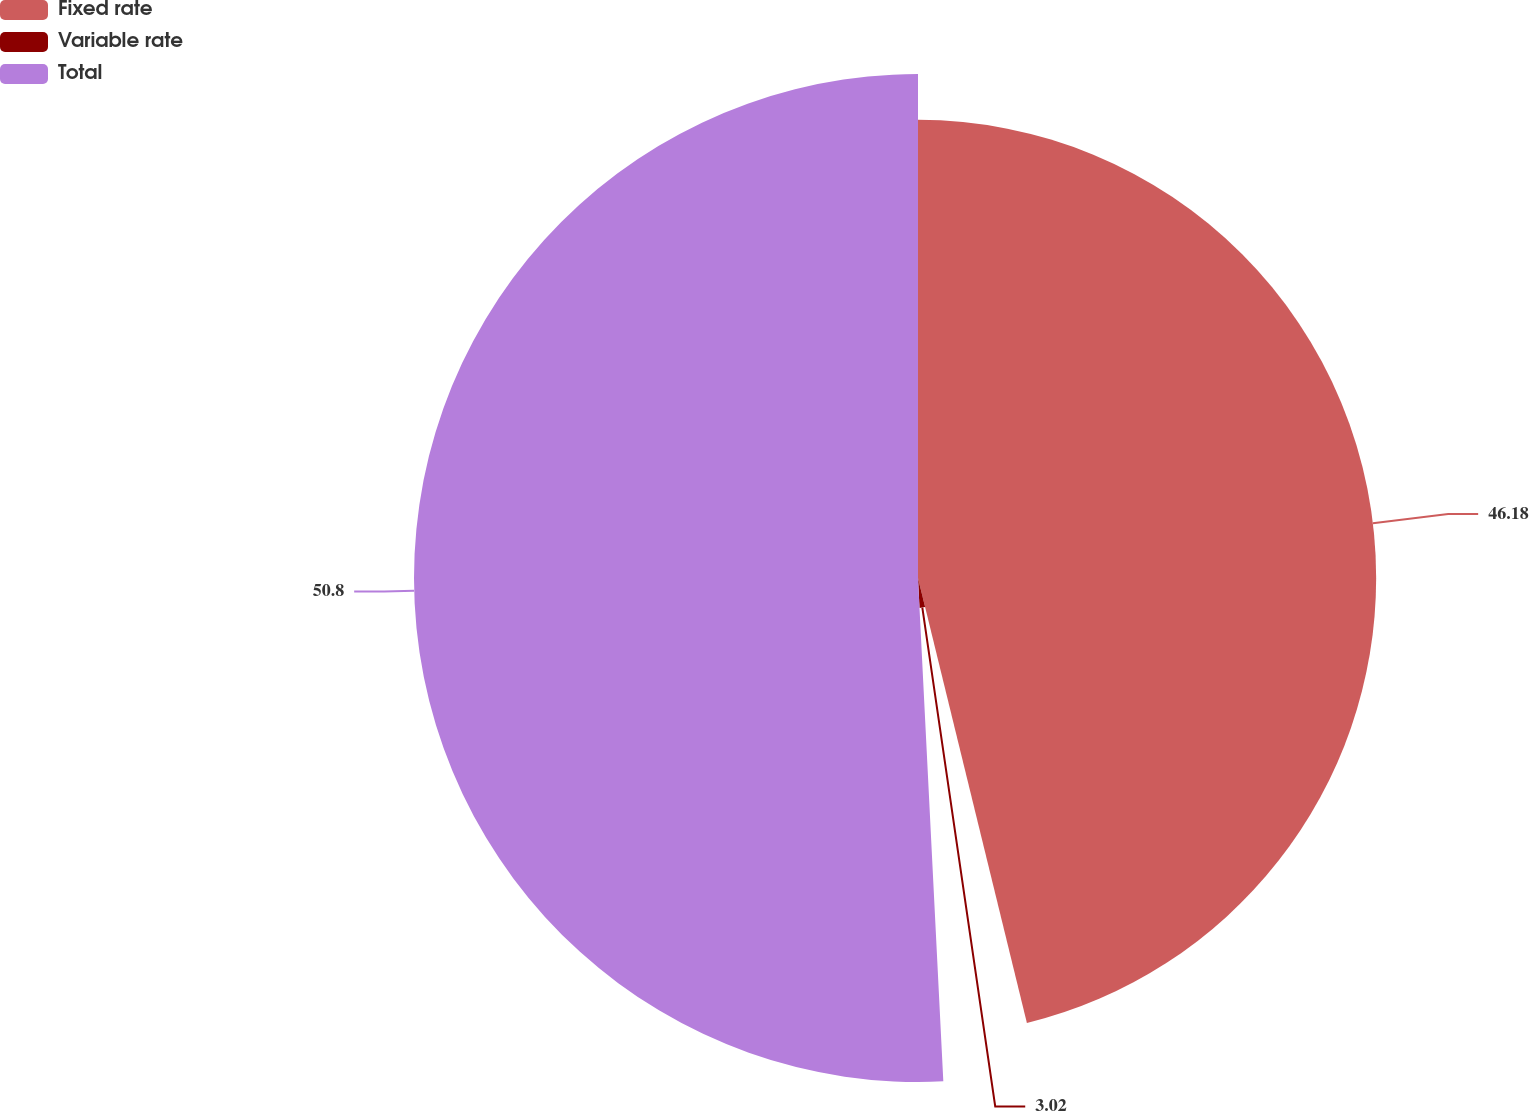Convert chart. <chart><loc_0><loc_0><loc_500><loc_500><pie_chart><fcel>Fixed rate<fcel>Variable rate<fcel>Total<nl><fcel>46.18%<fcel>3.02%<fcel>50.8%<nl></chart> 